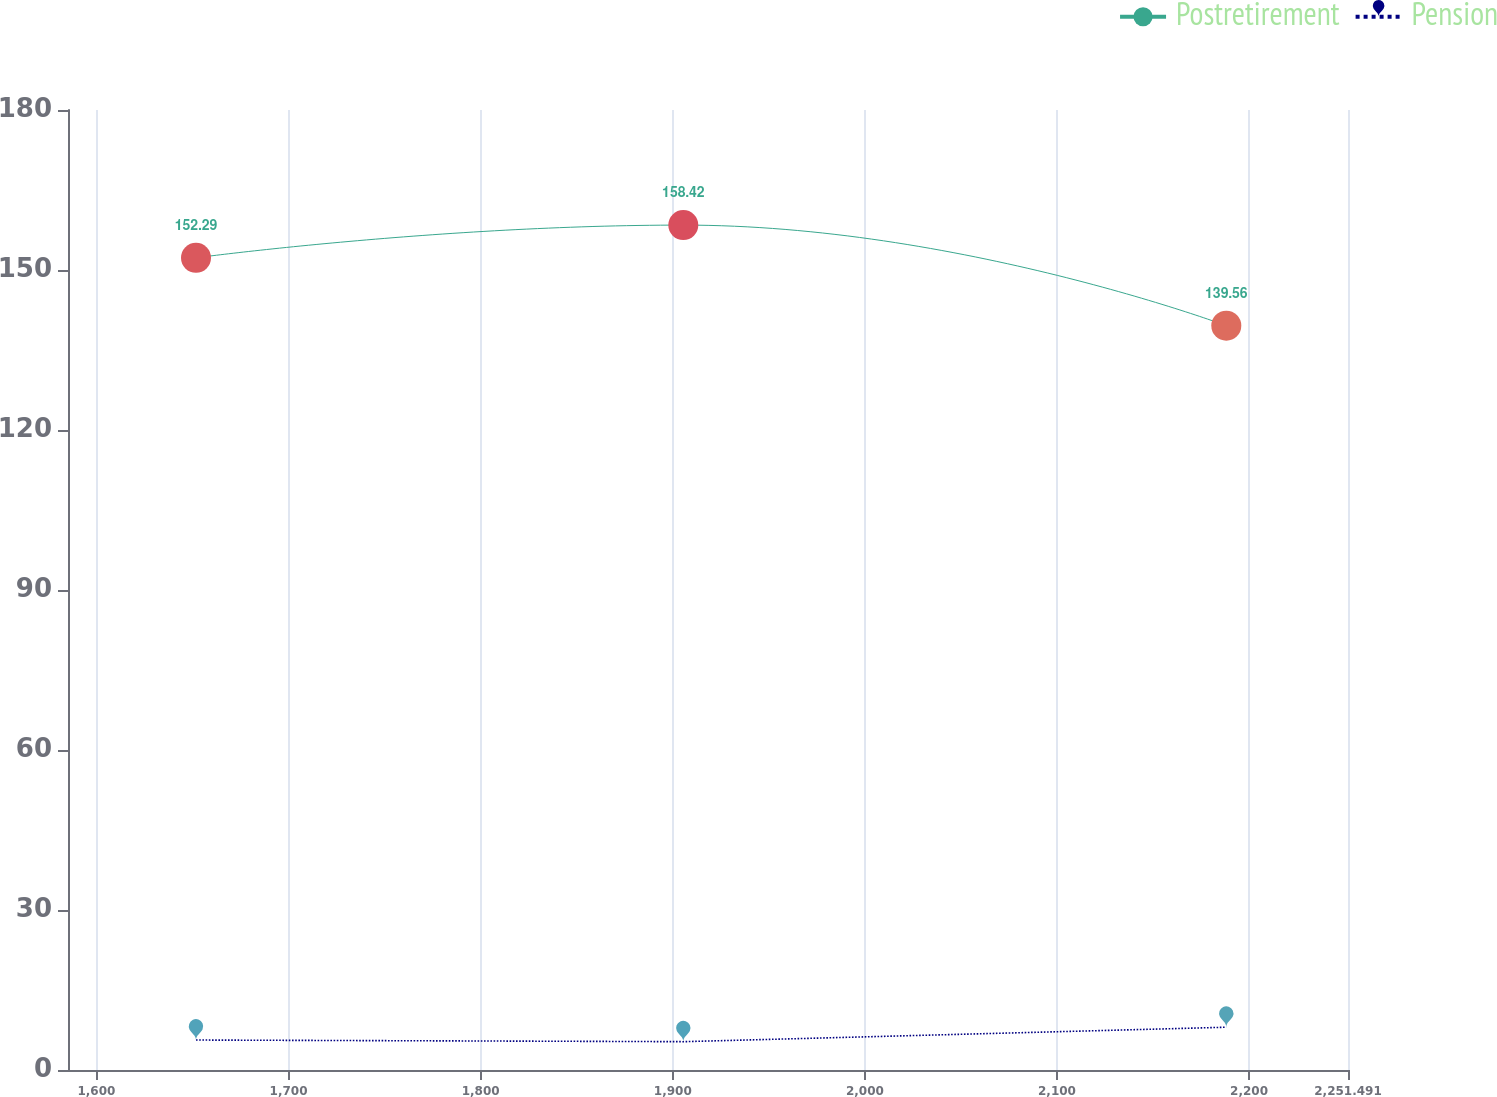<chart> <loc_0><loc_0><loc_500><loc_500><line_chart><ecel><fcel>Postretirement<fcel>Pension<nl><fcel>1651.83<fcel>152.29<fcel>5.62<nl><fcel>1905.49<fcel>158.42<fcel>5.31<nl><fcel>2188.14<fcel>139.56<fcel>8.02<nl><fcel>2253.13<fcel>137.46<fcel>7.71<nl><fcel>2318.12<fcel>145.71<fcel>8.39<nl></chart> 